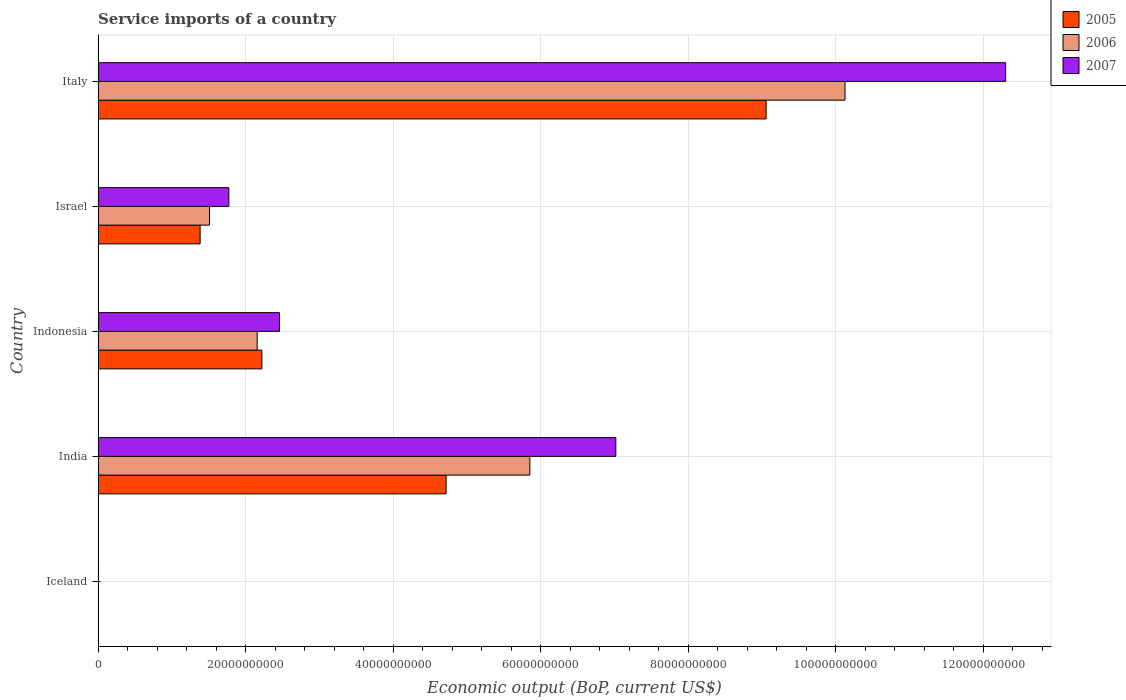How many different coloured bars are there?
Give a very brief answer. 3. Are the number of bars per tick equal to the number of legend labels?
Your answer should be very brief. Yes. Are the number of bars on each tick of the Y-axis equal?
Offer a very short reply. Yes. How many bars are there on the 2nd tick from the bottom?
Keep it short and to the point. 3. In how many cases, is the number of bars for a given country not equal to the number of legend labels?
Offer a terse response. 0. What is the service imports in 2006 in Italy?
Offer a terse response. 1.01e+11. Across all countries, what is the maximum service imports in 2005?
Provide a short and direct response. 9.05e+1. Across all countries, what is the minimum service imports in 2006?
Your answer should be compact. 2.89e+07. In which country was the service imports in 2007 maximum?
Provide a succinct answer. Italy. What is the total service imports in 2007 in the graph?
Make the answer very short. 2.36e+11. What is the difference between the service imports in 2007 in India and that in Israel?
Keep it short and to the point. 5.25e+1. What is the difference between the service imports in 2007 in Israel and the service imports in 2005 in India?
Make the answer very short. -2.94e+1. What is the average service imports in 2005 per country?
Ensure brevity in your answer.  3.47e+1. What is the difference between the service imports in 2006 and service imports in 2007 in Indonesia?
Your answer should be very brief. -3.02e+09. In how many countries, is the service imports in 2005 greater than 8000000000 US$?
Your answer should be compact. 4. What is the ratio of the service imports in 2005 in Iceland to that in Italy?
Make the answer very short. 0. Is the service imports in 2007 in Iceland less than that in India?
Ensure brevity in your answer.  Yes. Is the difference between the service imports in 2006 in Iceland and Israel greater than the difference between the service imports in 2007 in Iceland and Israel?
Your answer should be very brief. Yes. What is the difference between the highest and the second highest service imports in 2007?
Your answer should be very brief. 5.28e+1. What is the difference between the highest and the lowest service imports in 2007?
Your response must be concise. 1.23e+11. In how many countries, is the service imports in 2006 greater than the average service imports in 2006 taken over all countries?
Provide a succinct answer. 2. What does the 2nd bar from the top in Indonesia represents?
Offer a very short reply. 2006. What does the 1st bar from the bottom in Italy represents?
Your answer should be compact. 2005. Is it the case that in every country, the sum of the service imports in 2006 and service imports in 2005 is greater than the service imports in 2007?
Your response must be concise. No. Are all the bars in the graph horizontal?
Offer a terse response. Yes. How many countries are there in the graph?
Provide a short and direct response. 5. What is the difference between two consecutive major ticks on the X-axis?
Give a very brief answer. 2.00e+1. What is the title of the graph?
Your answer should be compact. Service imports of a country. Does "1981" appear as one of the legend labels in the graph?
Provide a short and direct response. No. What is the label or title of the X-axis?
Give a very brief answer. Economic output (BoP, current US$). What is the Economic output (BoP, current US$) in 2005 in Iceland?
Offer a very short reply. 1.32e+07. What is the Economic output (BoP, current US$) of 2006 in Iceland?
Make the answer very short. 2.89e+07. What is the Economic output (BoP, current US$) of 2007 in Iceland?
Keep it short and to the point. 5.90e+07. What is the Economic output (BoP, current US$) of 2005 in India?
Provide a succinct answer. 4.72e+1. What is the Economic output (BoP, current US$) in 2006 in India?
Make the answer very short. 5.85e+1. What is the Economic output (BoP, current US$) in 2007 in India?
Offer a very short reply. 7.02e+1. What is the Economic output (BoP, current US$) of 2005 in Indonesia?
Offer a terse response. 2.22e+1. What is the Economic output (BoP, current US$) in 2006 in Indonesia?
Your response must be concise. 2.16e+1. What is the Economic output (BoP, current US$) of 2007 in Indonesia?
Provide a short and direct response. 2.46e+1. What is the Economic output (BoP, current US$) in 2005 in Israel?
Your answer should be compact. 1.38e+1. What is the Economic output (BoP, current US$) of 2006 in Israel?
Provide a short and direct response. 1.51e+1. What is the Economic output (BoP, current US$) of 2007 in Israel?
Keep it short and to the point. 1.77e+1. What is the Economic output (BoP, current US$) in 2005 in Italy?
Keep it short and to the point. 9.05e+1. What is the Economic output (BoP, current US$) in 2006 in Italy?
Your answer should be compact. 1.01e+11. What is the Economic output (BoP, current US$) of 2007 in Italy?
Your response must be concise. 1.23e+11. Across all countries, what is the maximum Economic output (BoP, current US$) of 2005?
Provide a short and direct response. 9.05e+1. Across all countries, what is the maximum Economic output (BoP, current US$) in 2006?
Offer a terse response. 1.01e+11. Across all countries, what is the maximum Economic output (BoP, current US$) of 2007?
Your response must be concise. 1.23e+11. Across all countries, what is the minimum Economic output (BoP, current US$) in 2005?
Your response must be concise. 1.32e+07. Across all countries, what is the minimum Economic output (BoP, current US$) in 2006?
Provide a short and direct response. 2.89e+07. Across all countries, what is the minimum Economic output (BoP, current US$) of 2007?
Keep it short and to the point. 5.90e+07. What is the total Economic output (BoP, current US$) in 2005 in the graph?
Your response must be concise. 1.74e+11. What is the total Economic output (BoP, current US$) in 2006 in the graph?
Offer a terse response. 1.96e+11. What is the total Economic output (BoP, current US$) in 2007 in the graph?
Your answer should be compact. 2.36e+11. What is the difference between the Economic output (BoP, current US$) in 2005 in Iceland and that in India?
Provide a short and direct response. -4.72e+1. What is the difference between the Economic output (BoP, current US$) of 2006 in Iceland and that in India?
Keep it short and to the point. -5.85e+1. What is the difference between the Economic output (BoP, current US$) in 2007 in Iceland and that in India?
Your answer should be very brief. -7.01e+1. What is the difference between the Economic output (BoP, current US$) of 2005 in Iceland and that in Indonesia?
Your answer should be very brief. -2.22e+1. What is the difference between the Economic output (BoP, current US$) of 2006 in Iceland and that in Indonesia?
Give a very brief answer. -2.15e+1. What is the difference between the Economic output (BoP, current US$) in 2007 in Iceland and that in Indonesia?
Provide a short and direct response. -2.45e+1. What is the difference between the Economic output (BoP, current US$) of 2005 in Iceland and that in Israel?
Make the answer very short. -1.38e+1. What is the difference between the Economic output (BoP, current US$) in 2006 in Iceland and that in Israel?
Your response must be concise. -1.51e+1. What is the difference between the Economic output (BoP, current US$) in 2007 in Iceland and that in Israel?
Your answer should be compact. -1.77e+1. What is the difference between the Economic output (BoP, current US$) in 2005 in Iceland and that in Italy?
Your response must be concise. -9.05e+1. What is the difference between the Economic output (BoP, current US$) of 2006 in Iceland and that in Italy?
Provide a succinct answer. -1.01e+11. What is the difference between the Economic output (BoP, current US$) of 2007 in Iceland and that in Italy?
Your answer should be compact. -1.23e+11. What is the difference between the Economic output (BoP, current US$) of 2005 in India and that in Indonesia?
Ensure brevity in your answer.  2.50e+1. What is the difference between the Economic output (BoP, current US$) in 2006 in India and that in Indonesia?
Provide a succinct answer. 3.70e+1. What is the difference between the Economic output (BoP, current US$) in 2007 in India and that in Indonesia?
Your response must be concise. 4.56e+1. What is the difference between the Economic output (BoP, current US$) of 2005 in India and that in Israel?
Offer a very short reply. 3.33e+1. What is the difference between the Economic output (BoP, current US$) of 2006 in India and that in Israel?
Offer a very short reply. 4.34e+1. What is the difference between the Economic output (BoP, current US$) of 2007 in India and that in Israel?
Your answer should be compact. 5.25e+1. What is the difference between the Economic output (BoP, current US$) in 2005 in India and that in Italy?
Offer a terse response. -4.34e+1. What is the difference between the Economic output (BoP, current US$) of 2006 in India and that in Italy?
Your response must be concise. -4.27e+1. What is the difference between the Economic output (BoP, current US$) in 2007 in India and that in Italy?
Your response must be concise. -5.28e+1. What is the difference between the Economic output (BoP, current US$) in 2005 in Indonesia and that in Israel?
Keep it short and to the point. 8.37e+09. What is the difference between the Economic output (BoP, current US$) in 2006 in Indonesia and that in Israel?
Ensure brevity in your answer.  6.47e+09. What is the difference between the Economic output (BoP, current US$) in 2007 in Indonesia and that in Israel?
Provide a succinct answer. 6.86e+09. What is the difference between the Economic output (BoP, current US$) in 2005 in Indonesia and that in Italy?
Give a very brief answer. -6.83e+1. What is the difference between the Economic output (BoP, current US$) in 2006 in Indonesia and that in Italy?
Keep it short and to the point. -7.97e+1. What is the difference between the Economic output (BoP, current US$) in 2007 in Indonesia and that in Italy?
Offer a terse response. -9.84e+1. What is the difference between the Economic output (BoP, current US$) of 2005 in Israel and that in Italy?
Offer a terse response. -7.67e+1. What is the difference between the Economic output (BoP, current US$) in 2006 in Israel and that in Italy?
Your answer should be compact. -8.61e+1. What is the difference between the Economic output (BoP, current US$) of 2007 in Israel and that in Italy?
Provide a succinct answer. -1.05e+11. What is the difference between the Economic output (BoP, current US$) of 2005 in Iceland and the Economic output (BoP, current US$) of 2006 in India?
Your response must be concise. -5.85e+1. What is the difference between the Economic output (BoP, current US$) in 2005 in Iceland and the Economic output (BoP, current US$) in 2007 in India?
Keep it short and to the point. -7.02e+1. What is the difference between the Economic output (BoP, current US$) of 2006 in Iceland and the Economic output (BoP, current US$) of 2007 in India?
Your answer should be very brief. -7.01e+1. What is the difference between the Economic output (BoP, current US$) in 2005 in Iceland and the Economic output (BoP, current US$) in 2006 in Indonesia?
Make the answer very short. -2.15e+1. What is the difference between the Economic output (BoP, current US$) in 2005 in Iceland and the Economic output (BoP, current US$) in 2007 in Indonesia?
Provide a short and direct response. -2.46e+1. What is the difference between the Economic output (BoP, current US$) in 2006 in Iceland and the Economic output (BoP, current US$) in 2007 in Indonesia?
Your answer should be very brief. -2.45e+1. What is the difference between the Economic output (BoP, current US$) in 2005 in Iceland and the Economic output (BoP, current US$) in 2006 in Israel?
Provide a short and direct response. -1.51e+1. What is the difference between the Economic output (BoP, current US$) in 2005 in Iceland and the Economic output (BoP, current US$) in 2007 in Israel?
Your answer should be very brief. -1.77e+1. What is the difference between the Economic output (BoP, current US$) of 2006 in Iceland and the Economic output (BoP, current US$) of 2007 in Israel?
Offer a terse response. -1.77e+1. What is the difference between the Economic output (BoP, current US$) in 2005 in Iceland and the Economic output (BoP, current US$) in 2006 in Italy?
Keep it short and to the point. -1.01e+11. What is the difference between the Economic output (BoP, current US$) in 2005 in Iceland and the Economic output (BoP, current US$) in 2007 in Italy?
Make the answer very short. -1.23e+11. What is the difference between the Economic output (BoP, current US$) of 2006 in Iceland and the Economic output (BoP, current US$) of 2007 in Italy?
Ensure brevity in your answer.  -1.23e+11. What is the difference between the Economic output (BoP, current US$) of 2005 in India and the Economic output (BoP, current US$) of 2006 in Indonesia?
Provide a short and direct response. 2.56e+1. What is the difference between the Economic output (BoP, current US$) in 2005 in India and the Economic output (BoP, current US$) in 2007 in Indonesia?
Offer a terse response. 2.26e+1. What is the difference between the Economic output (BoP, current US$) of 2006 in India and the Economic output (BoP, current US$) of 2007 in Indonesia?
Ensure brevity in your answer.  3.39e+1. What is the difference between the Economic output (BoP, current US$) in 2005 in India and the Economic output (BoP, current US$) in 2006 in Israel?
Your answer should be compact. 3.21e+1. What is the difference between the Economic output (BoP, current US$) in 2005 in India and the Economic output (BoP, current US$) in 2007 in Israel?
Offer a very short reply. 2.94e+1. What is the difference between the Economic output (BoP, current US$) of 2006 in India and the Economic output (BoP, current US$) of 2007 in Israel?
Your answer should be very brief. 4.08e+1. What is the difference between the Economic output (BoP, current US$) of 2005 in India and the Economic output (BoP, current US$) of 2006 in Italy?
Your answer should be compact. -5.41e+1. What is the difference between the Economic output (BoP, current US$) of 2005 in India and the Economic output (BoP, current US$) of 2007 in Italy?
Give a very brief answer. -7.58e+1. What is the difference between the Economic output (BoP, current US$) in 2006 in India and the Economic output (BoP, current US$) in 2007 in Italy?
Your response must be concise. -6.45e+1. What is the difference between the Economic output (BoP, current US$) of 2005 in Indonesia and the Economic output (BoP, current US$) of 2006 in Israel?
Offer a terse response. 7.10e+09. What is the difference between the Economic output (BoP, current US$) in 2005 in Indonesia and the Economic output (BoP, current US$) in 2007 in Israel?
Offer a very short reply. 4.48e+09. What is the difference between the Economic output (BoP, current US$) of 2006 in Indonesia and the Economic output (BoP, current US$) of 2007 in Israel?
Your answer should be compact. 3.84e+09. What is the difference between the Economic output (BoP, current US$) in 2005 in Indonesia and the Economic output (BoP, current US$) in 2006 in Italy?
Offer a terse response. -7.90e+1. What is the difference between the Economic output (BoP, current US$) in 2005 in Indonesia and the Economic output (BoP, current US$) in 2007 in Italy?
Provide a short and direct response. -1.01e+11. What is the difference between the Economic output (BoP, current US$) of 2006 in Indonesia and the Economic output (BoP, current US$) of 2007 in Italy?
Your answer should be very brief. -1.01e+11. What is the difference between the Economic output (BoP, current US$) of 2005 in Israel and the Economic output (BoP, current US$) of 2006 in Italy?
Your answer should be very brief. -8.74e+1. What is the difference between the Economic output (BoP, current US$) in 2005 in Israel and the Economic output (BoP, current US$) in 2007 in Italy?
Keep it short and to the point. -1.09e+11. What is the difference between the Economic output (BoP, current US$) in 2006 in Israel and the Economic output (BoP, current US$) in 2007 in Italy?
Provide a short and direct response. -1.08e+11. What is the average Economic output (BoP, current US$) of 2005 per country?
Provide a short and direct response. 3.47e+1. What is the average Economic output (BoP, current US$) in 2006 per country?
Offer a very short reply. 3.93e+1. What is the average Economic output (BoP, current US$) of 2007 per country?
Give a very brief answer. 4.71e+1. What is the difference between the Economic output (BoP, current US$) of 2005 and Economic output (BoP, current US$) of 2006 in Iceland?
Provide a short and direct response. -1.57e+07. What is the difference between the Economic output (BoP, current US$) in 2005 and Economic output (BoP, current US$) in 2007 in Iceland?
Provide a short and direct response. -4.58e+07. What is the difference between the Economic output (BoP, current US$) in 2006 and Economic output (BoP, current US$) in 2007 in Iceland?
Keep it short and to the point. -3.01e+07. What is the difference between the Economic output (BoP, current US$) of 2005 and Economic output (BoP, current US$) of 2006 in India?
Give a very brief answer. -1.13e+1. What is the difference between the Economic output (BoP, current US$) of 2005 and Economic output (BoP, current US$) of 2007 in India?
Your answer should be very brief. -2.30e+1. What is the difference between the Economic output (BoP, current US$) in 2006 and Economic output (BoP, current US$) in 2007 in India?
Your answer should be very brief. -1.17e+1. What is the difference between the Economic output (BoP, current US$) in 2005 and Economic output (BoP, current US$) in 2006 in Indonesia?
Your response must be concise. 6.36e+08. What is the difference between the Economic output (BoP, current US$) in 2005 and Economic output (BoP, current US$) in 2007 in Indonesia?
Keep it short and to the point. -2.38e+09. What is the difference between the Economic output (BoP, current US$) in 2006 and Economic output (BoP, current US$) in 2007 in Indonesia?
Make the answer very short. -3.02e+09. What is the difference between the Economic output (BoP, current US$) of 2005 and Economic output (BoP, current US$) of 2006 in Israel?
Provide a succinct answer. -1.27e+09. What is the difference between the Economic output (BoP, current US$) in 2005 and Economic output (BoP, current US$) in 2007 in Israel?
Ensure brevity in your answer.  -3.89e+09. What is the difference between the Economic output (BoP, current US$) of 2006 and Economic output (BoP, current US$) of 2007 in Israel?
Your answer should be very brief. -2.62e+09. What is the difference between the Economic output (BoP, current US$) of 2005 and Economic output (BoP, current US$) of 2006 in Italy?
Make the answer very short. -1.07e+1. What is the difference between the Economic output (BoP, current US$) in 2005 and Economic output (BoP, current US$) in 2007 in Italy?
Offer a very short reply. -3.25e+1. What is the difference between the Economic output (BoP, current US$) of 2006 and Economic output (BoP, current US$) of 2007 in Italy?
Ensure brevity in your answer.  -2.18e+1. What is the ratio of the Economic output (BoP, current US$) of 2007 in Iceland to that in India?
Provide a succinct answer. 0. What is the ratio of the Economic output (BoP, current US$) in 2005 in Iceland to that in Indonesia?
Ensure brevity in your answer.  0. What is the ratio of the Economic output (BoP, current US$) in 2006 in Iceland to that in Indonesia?
Give a very brief answer. 0. What is the ratio of the Economic output (BoP, current US$) in 2007 in Iceland to that in Indonesia?
Your answer should be very brief. 0. What is the ratio of the Economic output (BoP, current US$) in 2006 in Iceland to that in Israel?
Your answer should be very brief. 0. What is the ratio of the Economic output (BoP, current US$) of 2007 in Iceland to that in Israel?
Your answer should be very brief. 0. What is the ratio of the Economic output (BoP, current US$) in 2005 in Iceland to that in Italy?
Your answer should be compact. 0. What is the ratio of the Economic output (BoP, current US$) in 2006 in Iceland to that in Italy?
Make the answer very short. 0. What is the ratio of the Economic output (BoP, current US$) of 2007 in Iceland to that in Italy?
Offer a very short reply. 0. What is the ratio of the Economic output (BoP, current US$) of 2005 in India to that in Indonesia?
Keep it short and to the point. 2.12. What is the ratio of the Economic output (BoP, current US$) of 2006 in India to that in Indonesia?
Make the answer very short. 2.71. What is the ratio of the Economic output (BoP, current US$) in 2007 in India to that in Indonesia?
Your answer should be very brief. 2.86. What is the ratio of the Economic output (BoP, current US$) of 2005 in India to that in Israel?
Your response must be concise. 3.41. What is the ratio of the Economic output (BoP, current US$) of 2006 in India to that in Israel?
Provide a short and direct response. 3.88. What is the ratio of the Economic output (BoP, current US$) of 2007 in India to that in Israel?
Your response must be concise. 3.96. What is the ratio of the Economic output (BoP, current US$) of 2005 in India to that in Italy?
Give a very brief answer. 0.52. What is the ratio of the Economic output (BoP, current US$) in 2006 in India to that in Italy?
Provide a succinct answer. 0.58. What is the ratio of the Economic output (BoP, current US$) of 2007 in India to that in Italy?
Provide a succinct answer. 0.57. What is the ratio of the Economic output (BoP, current US$) of 2005 in Indonesia to that in Israel?
Offer a very short reply. 1.61. What is the ratio of the Economic output (BoP, current US$) in 2006 in Indonesia to that in Israel?
Keep it short and to the point. 1.43. What is the ratio of the Economic output (BoP, current US$) of 2007 in Indonesia to that in Israel?
Your response must be concise. 1.39. What is the ratio of the Economic output (BoP, current US$) in 2005 in Indonesia to that in Italy?
Your answer should be very brief. 0.25. What is the ratio of the Economic output (BoP, current US$) in 2006 in Indonesia to that in Italy?
Give a very brief answer. 0.21. What is the ratio of the Economic output (BoP, current US$) in 2007 in Indonesia to that in Italy?
Your answer should be very brief. 0.2. What is the ratio of the Economic output (BoP, current US$) in 2005 in Israel to that in Italy?
Provide a short and direct response. 0.15. What is the ratio of the Economic output (BoP, current US$) in 2006 in Israel to that in Italy?
Offer a terse response. 0.15. What is the ratio of the Economic output (BoP, current US$) of 2007 in Israel to that in Italy?
Keep it short and to the point. 0.14. What is the difference between the highest and the second highest Economic output (BoP, current US$) of 2005?
Offer a very short reply. 4.34e+1. What is the difference between the highest and the second highest Economic output (BoP, current US$) in 2006?
Your answer should be very brief. 4.27e+1. What is the difference between the highest and the second highest Economic output (BoP, current US$) of 2007?
Ensure brevity in your answer.  5.28e+1. What is the difference between the highest and the lowest Economic output (BoP, current US$) of 2005?
Offer a terse response. 9.05e+1. What is the difference between the highest and the lowest Economic output (BoP, current US$) of 2006?
Ensure brevity in your answer.  1.01e+11. What is the difference between the highest and the lowest Economic output (BoP, current US$) of 2007?
Provide a short and direct response. 1.23e+11. 